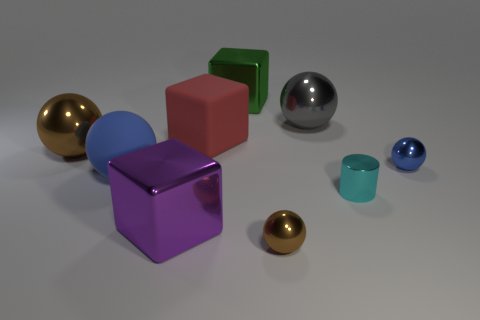Can you describe the arrangement of colors present among the items? Certainly. The objects exhibit a diverse palette, with each item having a distinctive color. From left to right, we have a gold sphere, a blue hemisphere, a purple cube, a pink cube, a large ball with a mirror-like surface, a small green cube, and finally, a small reflective sphere next to a small blue sphere. The arrangement forms a color gradient ranging from warm gold on the left, through cool blues and purples in the middle, to vivid green and calming blue on the right. 